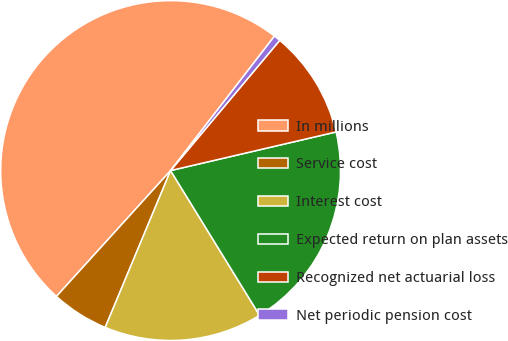<chart> <loc_0><loc_0><loc_500><loc_500><pie_chart><fcel>In millions<fcel>Service cost<fcel>Interest cost<fcel>Expected return on plan assets<fcel>Recognized net actuarial loss<fcel>Net periodic pension cost<nl><fcel>48.74%<fcel>5.44%<fcel>15.06%<fcel>19.87%<fcel>10.25%<fcel>0.63%<nl></chart> 